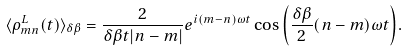Convert formula to latex. <formula><loc_0><loc_0><loc_500><loc_500>\langle \rho _ { m n } ^ { L } ( t ) \rangle _ { \delta \beta } = \frac { 2 } { \delta \beta t | n - m | } e ^ { i ( m - n ) \omega t } \cos { \left ( \frac { \delta \beta } { 2 } ( n - m ) \omega t \right ) } .</formula> 